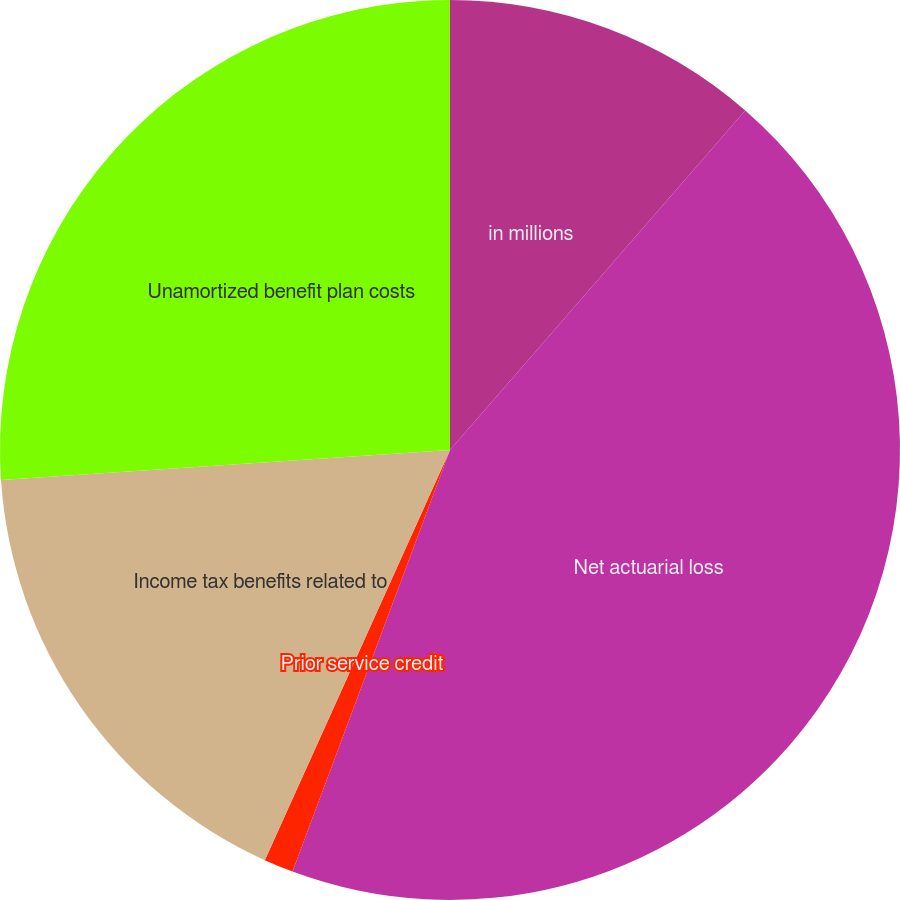<chart> <loc_0><loc_0><loc_500><loc_500><pie_chart><fcel>in millions<fcel>Net actuarial loss<fcel>Prior service credit<fcel>Income tax benefits related to<fcel>Unamortized benefit plan costs<nl><fcel>11.39%<fcel>44.3%<fcel>1.06%<fcel>17.19%<fcel>26.06%<nl></chart> 